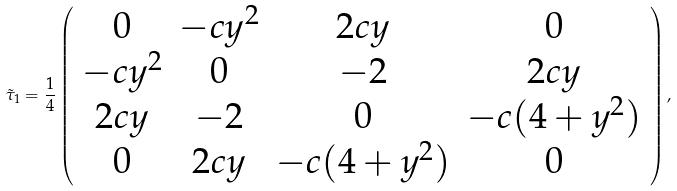<formula> <loc_0><loc_0><loc_500><loc_500>\tilde { \tau } _ { 1 } = \frac { 1 } { 4 } \left ( \begin{array} { c c c c } 0 & - c y ^ { 2 } & 2 c y & 0 \\ - c y ^ { 2 } & 0 & - 2 & 2 c y \\ 2 c y & - 2 & 0 & - c ( 4 + y ^ { 2 } ) \\ 0 & 2 c y & - c ( 4 + y ^ { 2 } ) & 0 \end{array} \right ) ,</formula> 